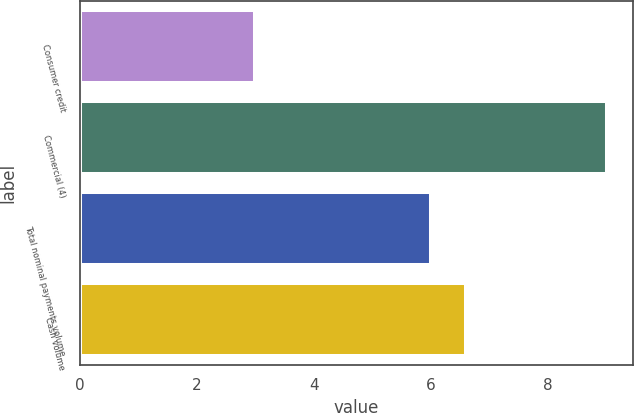Convert chart. <chart><loc_0><loc_0><loc_500><loc_500><bar_chart><fcel>Consumer credit<fcel>Commercial (4)<fcel>Total nominal payments volume<fcel>Cash volume<nl><fcel>3<fcel>9<fcel>6<fcel>6.6<nl></chart> 